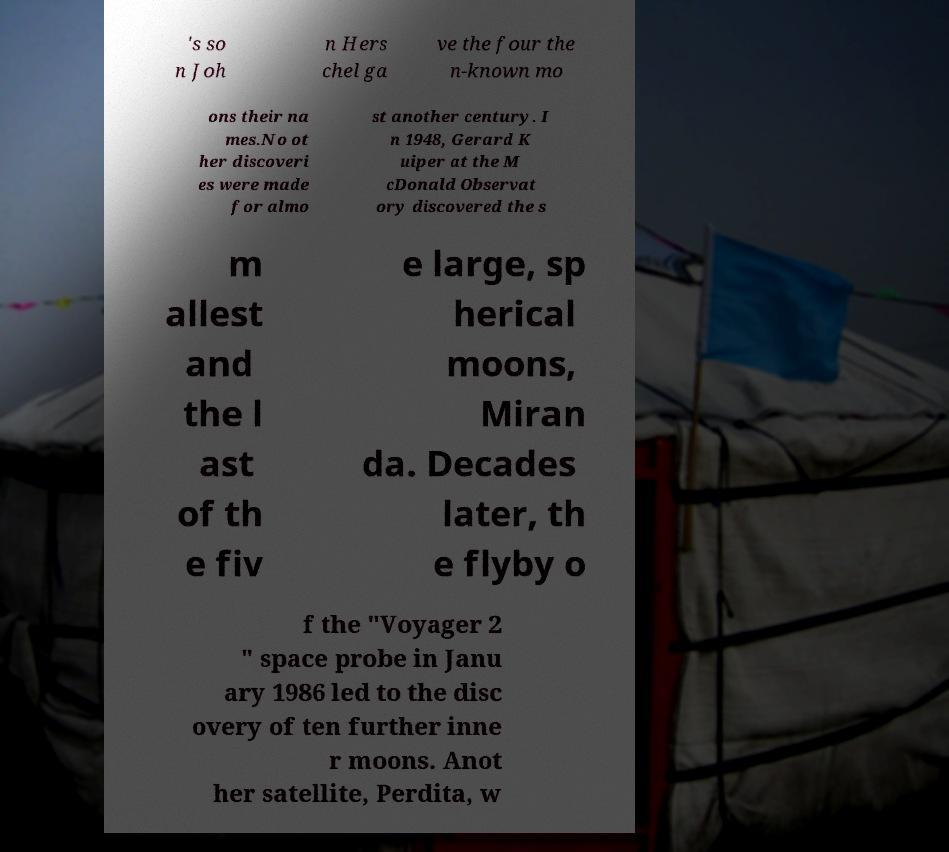Please identify and transcribe the text found in this image. 's so n Joh n Hers chel ga ve the four the n-known mo ons their na mes.No ot her discoveri es were made for almo st another century. I n 1948, Gerard K uiper at the M cDonald Observat ory discovered the s m allest and the l ast of th e fiv e large, sp herical moons, Miran da. Decades later, th e flyby o f the "Voyager 2 " space probe in Janu ary 1986 led to the disc overy of ten further inne r moons. Anot her satellite, Perdita, w 